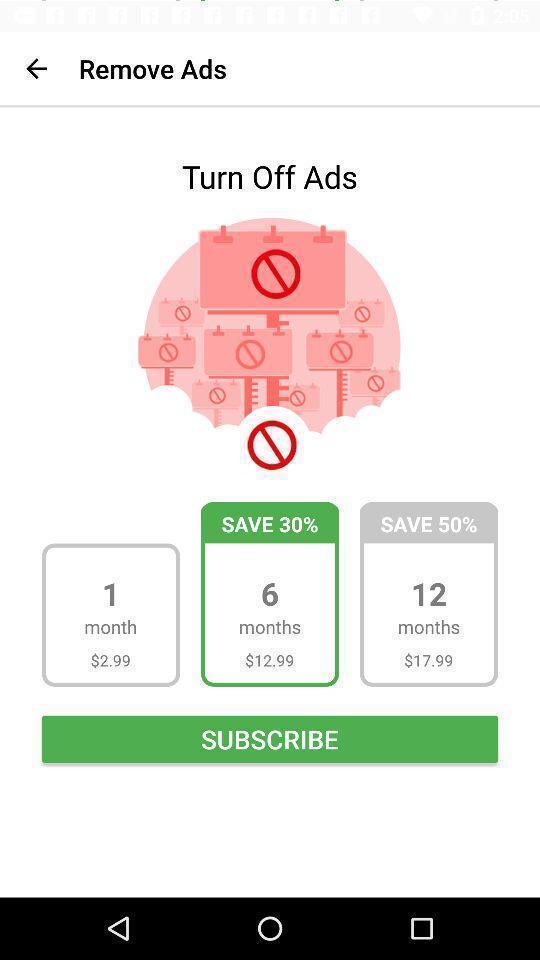What can you discern from this picture? Turn off ads in remove ads. 